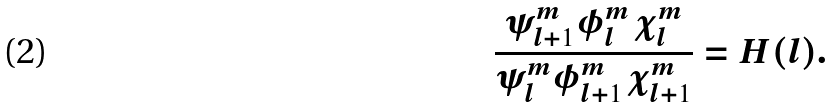Convert formula to latex. <formula><loc_0><loc_0><loc_500><loc_500>\frac { \psi _ { l + 1 } ^ { m } \phi _ { l } ^ { m } \chi _ { l } ^ { m } } { \psi _ { l } ^ { m } \phi _ { l + 1 } ^ { m } \chi _ { l + 1 } ^ { m } } = H ( l ) .</formula> 